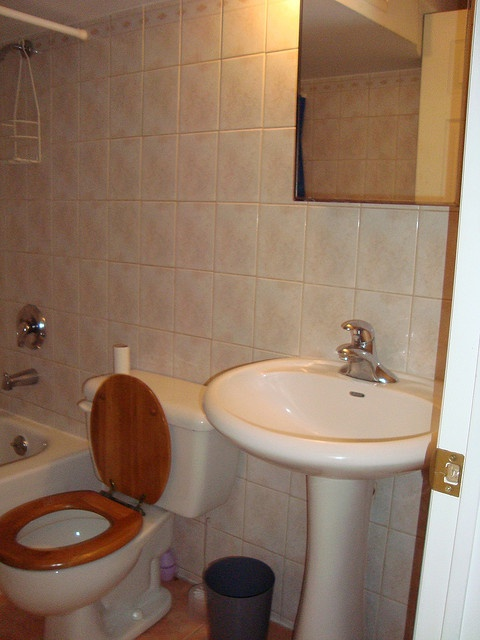Describe the objects in this image and their specific colors. I can see toilet in brown, maroon, gray, and tan tones and sink in brown, tan, darkgray, and gray tones in this image. 